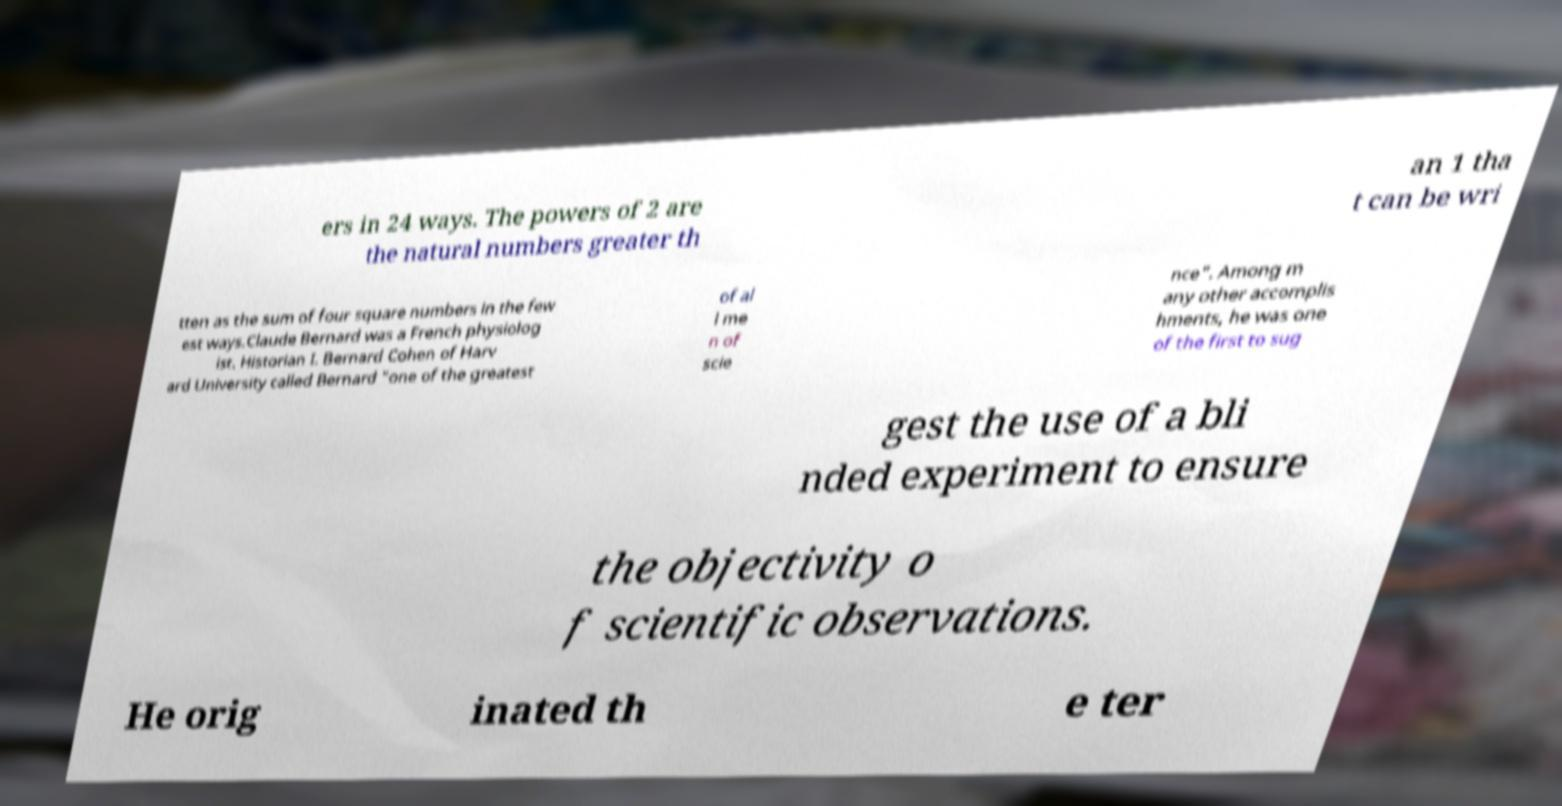Please identify and transcribe the text found in this image. ers in 24 ways. The powers of 2 are the natural numbers greater th an 1 tha t can be wri tten as the sum of four square numbers in the few est ways.Claude Bernard was a French physiolog ist. Historian I. Bernard Cohen of Harv ard University called Bernard "one of the greatest of al l me n of scie nce". Among m any other accomplis hments, he was one of the first to sug gest the use of a bli nded experiment to ensure the objectivity o f scientific observations. He orig inated th e ter 